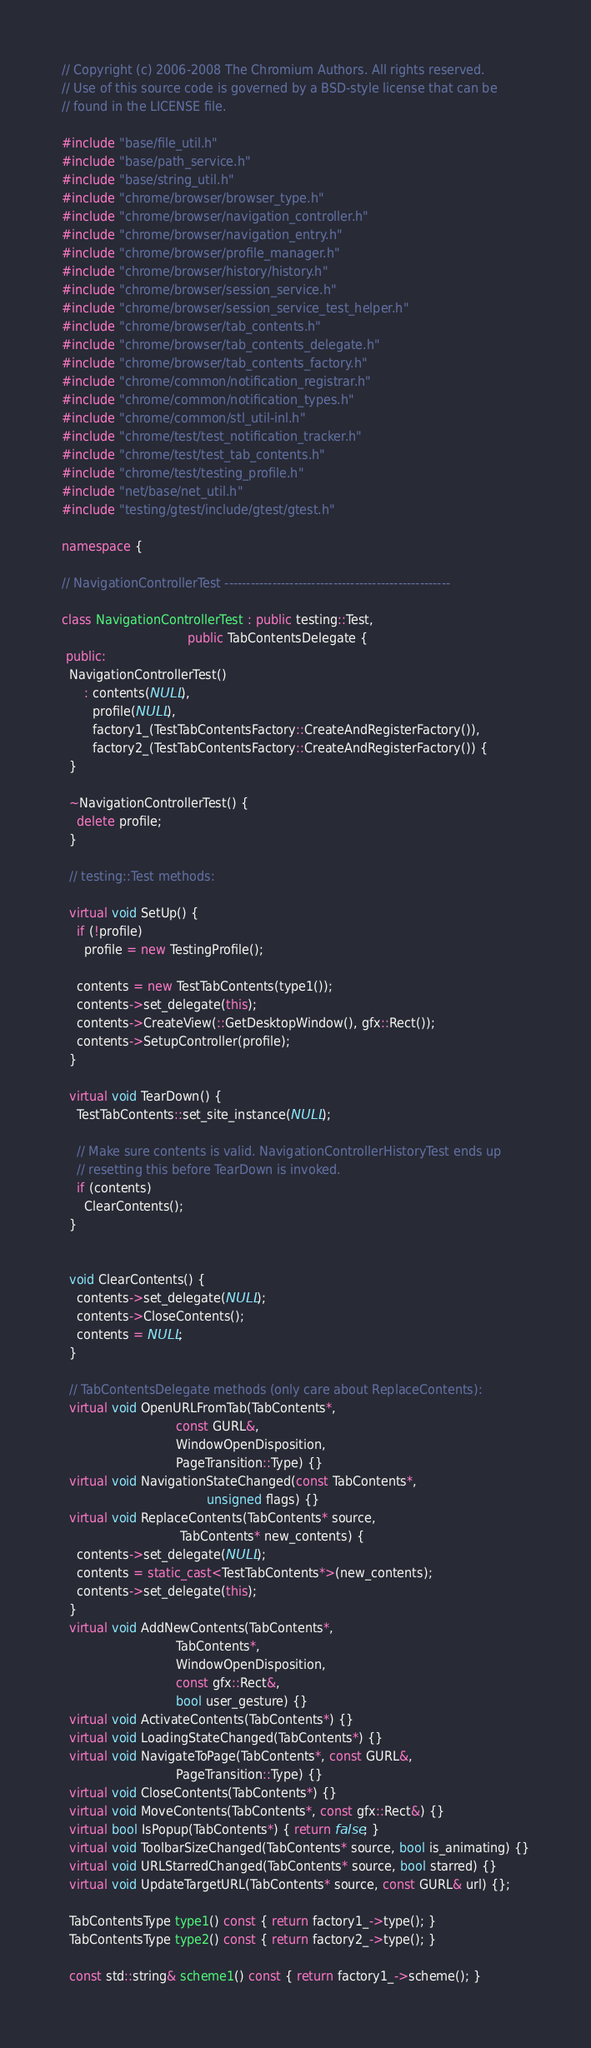<code> <loc_0><loc_0><loc_500><loc_500><_C++_>// Copyright (c) 2006-2008 The Chromium Authors. All rights reserved.
// Use of this source code is governed by a BSD-style license that can be
// found in the LICENSE file.

#include "base/file_util.h"
#include "base/path_service.h"
#include "base/string_util.h"
#include "chrome/browser/browser_type.h"
#include "chrome/browser/navigation_controller.h"
#include "chrome/browser/navigation_entry.h"
#include "chrome/browser/profile_manager.h"
#include "chrome/browser/history/history.h"
#include "chrome/browser/session_service.h"
#include "chrome/browser/session_service_test_helper.h"
#include "chrome/browser/tab_contents.h"
#include "chrome/browser/tab_contents_delegate.h"
#include "chrome/browser/tab_contents_factory.h"
#include "chrome/common/notification_registrar.h"
#include "chrome/common/notification_types.h"
#include "chrome/common/stl_util-inl.h"
#include "chrome/test/test_notification_tracker.h"
#include "chrome/test/test_tab_contents.h"
#include "chrome/test/testing_profile.h"
#include "net/base/net_util.h"
#include "testing/gtest/include/gtest/gtest.h"

namespace {

// NavigationControllerTest ----------------------------------------------------

class NavigationControllerTest : public testing::Test,
                                 public TabContentsDelegate {
 public:
  NavigationControllerTest()
      : contents(NULL),
        profile(NULL),
        factory1_(TestTabContentsFactory::CreateAndRegisterFactory()),
        factory2_(TestTabContentsFactory::CreateAndRegisterFactory()) {
  }

  ~NavigationControllerTest() {
    delete profile;
  }

  // testing::Test methods:

  virtual void SetUp() {
    if (!profile)
      profile = new TestingProfile();

    contents = new TestTabContents(type1());
    contents->set_delegate(this);
    contents->CreateView(::GetDesktopWindow(), gfx::Rect());
    contents->SetupController(profile);
  }

  virtual void TearDown() {
    TestTabContents::set_site_instance(NULL);

    // Make sure contents is valid. NavigationControllerHistoryTest ends up
    // resetting this before TearDown is invoked.
    if (contents)
      ClearContents();
  }


  void ClearContents() {
    contents->set_delegate(NULL);
    contents->CloseContents();
    contents = NULL;
  }

  // TabContentsDelegate methods (only care about ReplaceContents):
  virtual void OpenURLFromTab(TabContents*,
                              const GURL&,
                              WindowOpenDisposition,
                              PageTransition::Type) {}
  virtual void NavigationStateChanged(const TabContents*,
                                      unsigned flags) {}
  virtual void ReplaceContents(TabContents* source,
                               TabContents* new_contents) {
    contents->set_delegate(NULL);
    contents = static_cast<TestTabContents*>(new_contents);
    contents->set_delegate(this);
  }
  virtual void AddNewContents(TabContents*,
                              TabContents*,
                              WindowOpenDisposition,
                              const gfx::Rect&,
                              bool user_gesture) {}
  virtual void ActivateContents(TabContents*) {}
  virtual void LoadingStateChanged(TabContents*) {}
  virtual void NavigateToPage(TabContents*, const GURL&,
                              PageTransition::Type) {}
  virtual void CloseContents(TabContents*) {}
  virtual void MoveContents(TabContents*, const gfx::Rect&) {}
  virtual bool IsPopup(TabContents*) { return false; }
  virtual void ToolbarSizeChanged(TabContents* source, bool is_animating) {}
  virtual void URLStarredChanged(TabContents* source, bool starred) {}
  virtual void UpdateTargetURL(TabContents* source, const GURL& url) {};

  TabContentsType type1() const { return factory1_->type(); }
  TabContentsType type2() const { return factory2_->type(); }

  const std::string& scheme1() const { return factory1_->scheme(); }</code> 